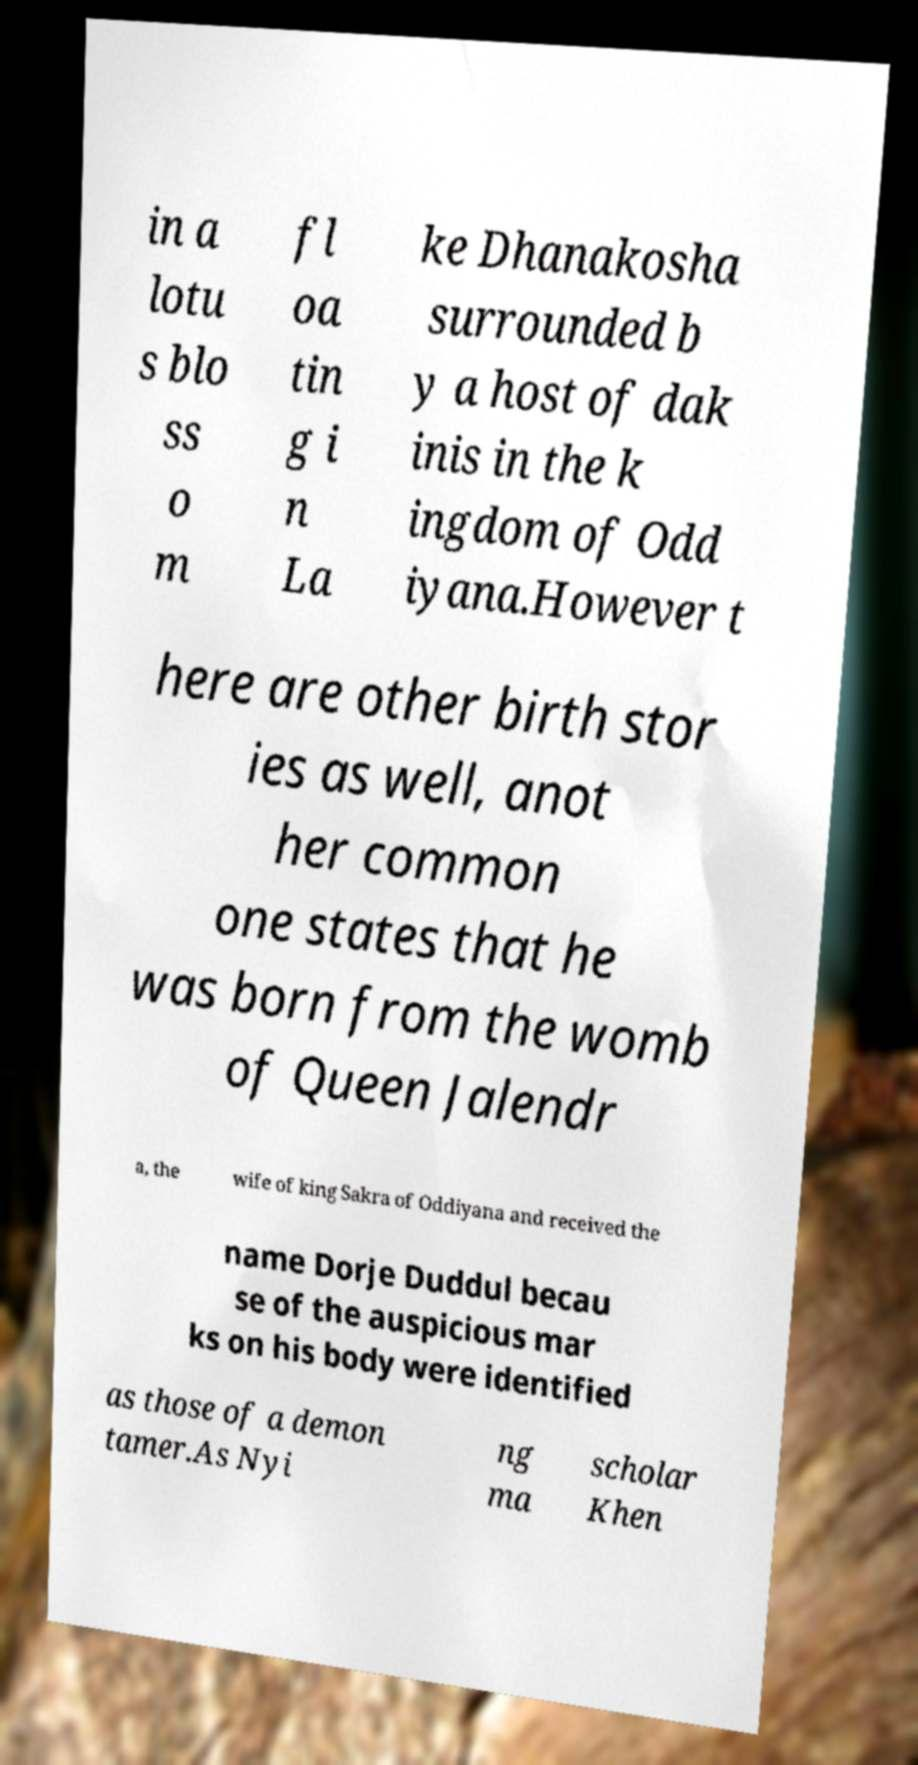I need the written content from this picture converted into text. Can you do that? in a lotu s blo ss o m fl oa tin g i n La ke Dhanakosha surrounded b y a host of dak inis in the k ingdom of Odd iyana.However t here are other birth stor ies as well, anot her common one states that he was born from the womb of Queen Jalendr a, the wife of king Sakra of Oddiyana and received the name Dorje Duddul becau se of the auspicious mar ks on his body were identified as those of a demon tamer.As Nyi ng ma scholar Khen 